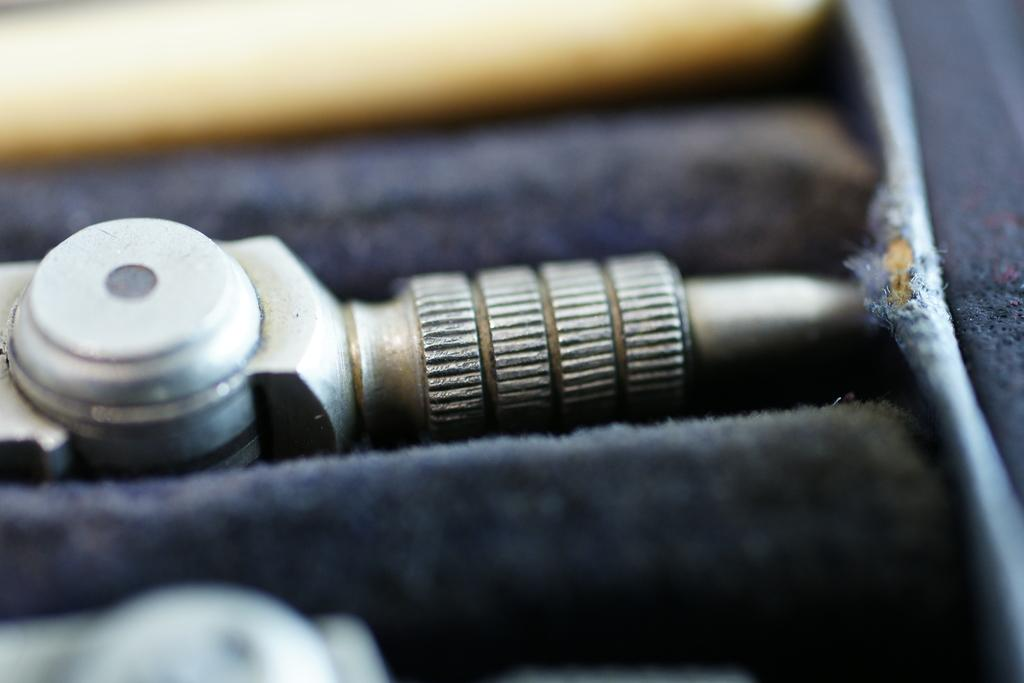What is the main object in the center of the image? There is a metal equipment in the center of the image. Can you describe any other objects or materials in the image? There is a cloth in the image. How does the metal equipment blow air in the image? The metal equipment does not blow air in the image; it is a static object. What role does the uncle play in the image? There is no uncle present in the image. 